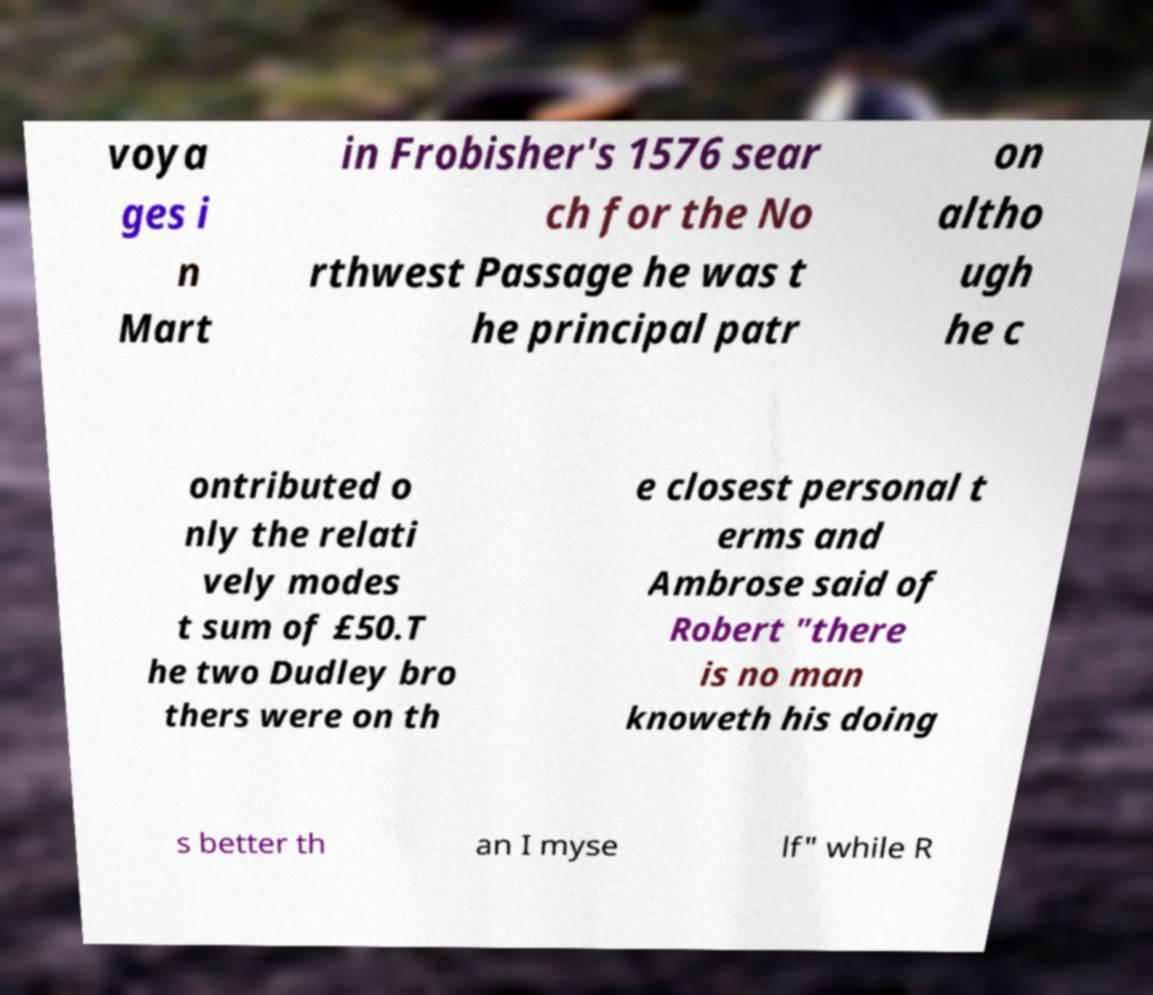Can you accurately transcribe the text from the provided image for me? voya ges i n Mart in Frobisher's 1576 sear ch for the No rthwest Passage he was t he principal patr on altho ugh he c ontributed o nly the relati vely modes t sum of £50.T he two Dudley bro thers were on th e closest personal t erms and Ambrose said of Robert "there is no man knoweth his doing s better th an I myse lf" while R 